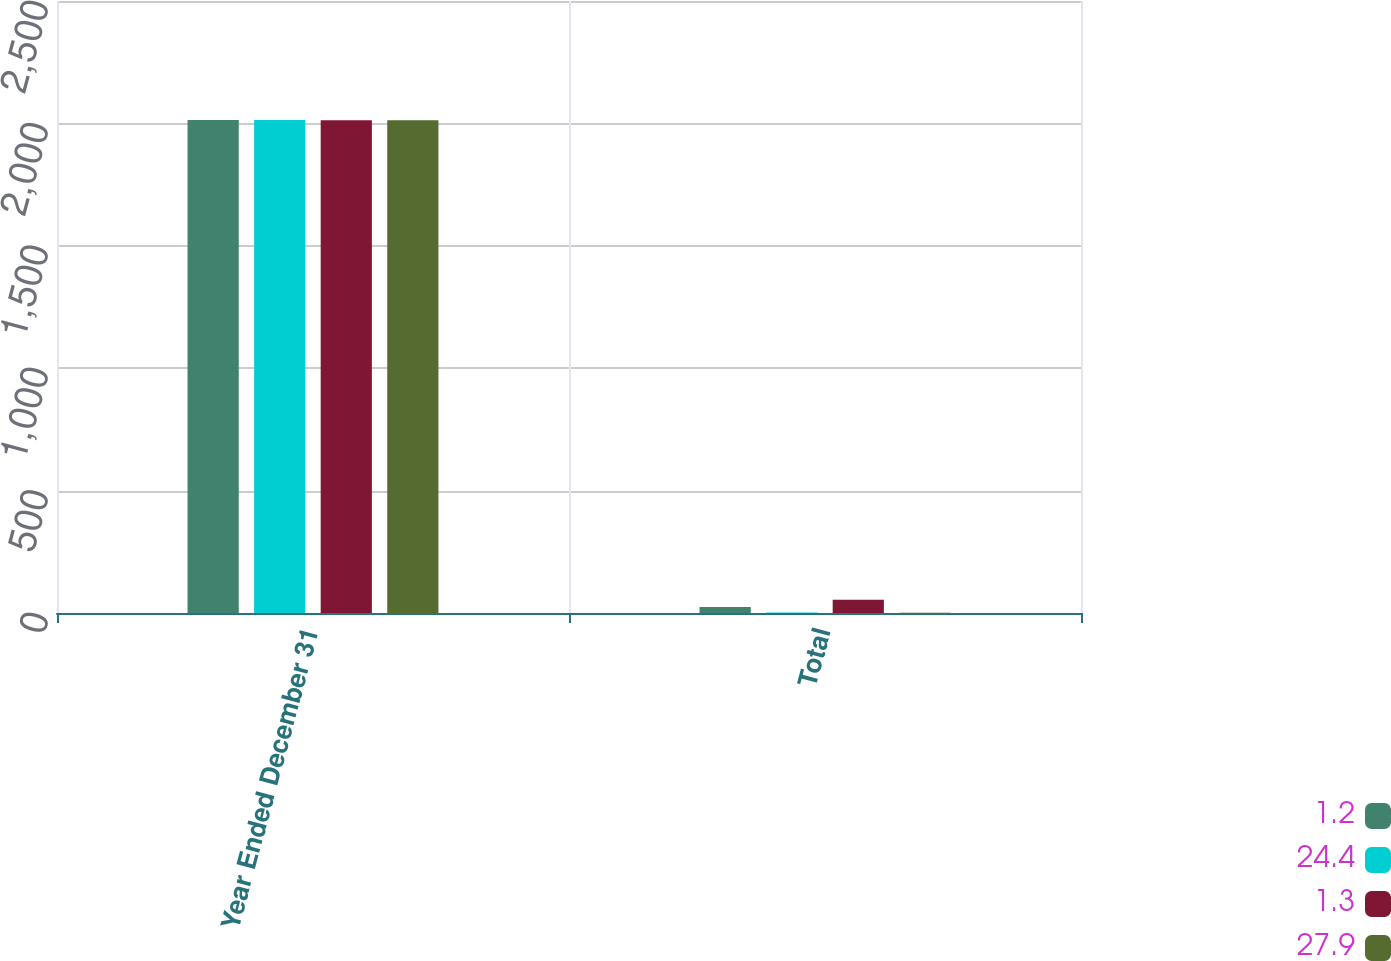Convert chart to OTSL. <chart><loc_0><loc_0><loc_500><loc_500><stacked_bar_chart><ecel><fcel>Year Ended December 31<fcel>Total<nl><fcel>1.2<fcel>2014<fcel>24.4<nl><fcel>24.4<fcel>2014<fcel>1.7<nl><fcel>1.3<fcel>2013<fcel>54.4<nl><fcel>27.9<fcel>2013<fcel>1.2<nl></chart> 